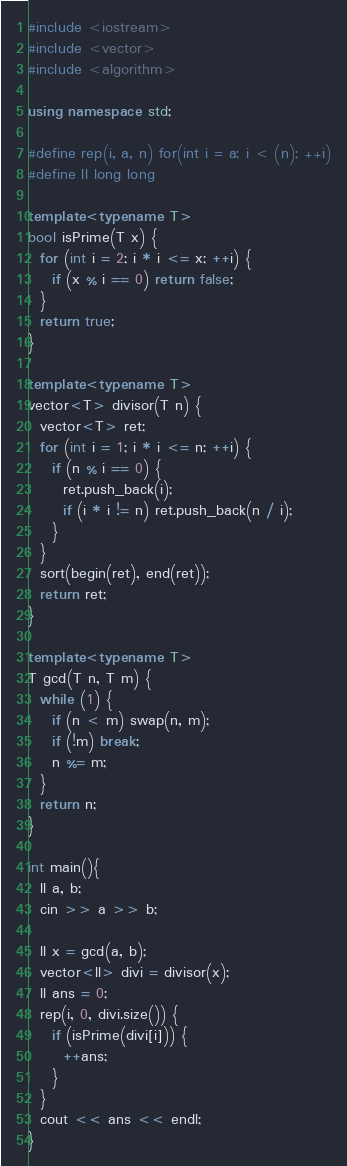Convert code to text. <code><loc_0><loc_0><loc_500><loc_500><_C++_>#include <iostream>
#include <vector>
#include <algorithm>

using namespace std;

#define rep(i, a, n) for(int i = a; i < (n); ++i)
#define ll long long

template<typename T>
bool isPrime(T x) {
  for (int i = 2; i * i <= x; ++i) {
    if (x % i == 0) return false;
  }
  return true;
}

template<typename T>
vector<T> divisor(T n) {
  vector<T> ret;
  for (int i = 1; i * i <= n; ++i) {
    if (n % i == 0) {
      ret.push_back(i);
      if (i * i != n) ret.push_back(n / i);
    }
  }
  sort(begin(ret), end(ret));
  return ret;
}

template<typename T>
T gcd(T n, T m) {
  while (1) {
    if (n < m) swap(n, m);
    if (!m) break;
    n %= m;
  }
  return n;
}

int main(){
  ll a, b;
  cin >> a >> b;
  
  ll x = gcd(a, b);
  vector<ll> divi = divisor(x);
  ll ans = 0;
  rep(i, 0, divi.size()) {
    if (isPrime(divi[i])) {
      ++ans;
    }
  }
  cout << ans << endl;
}</code> 